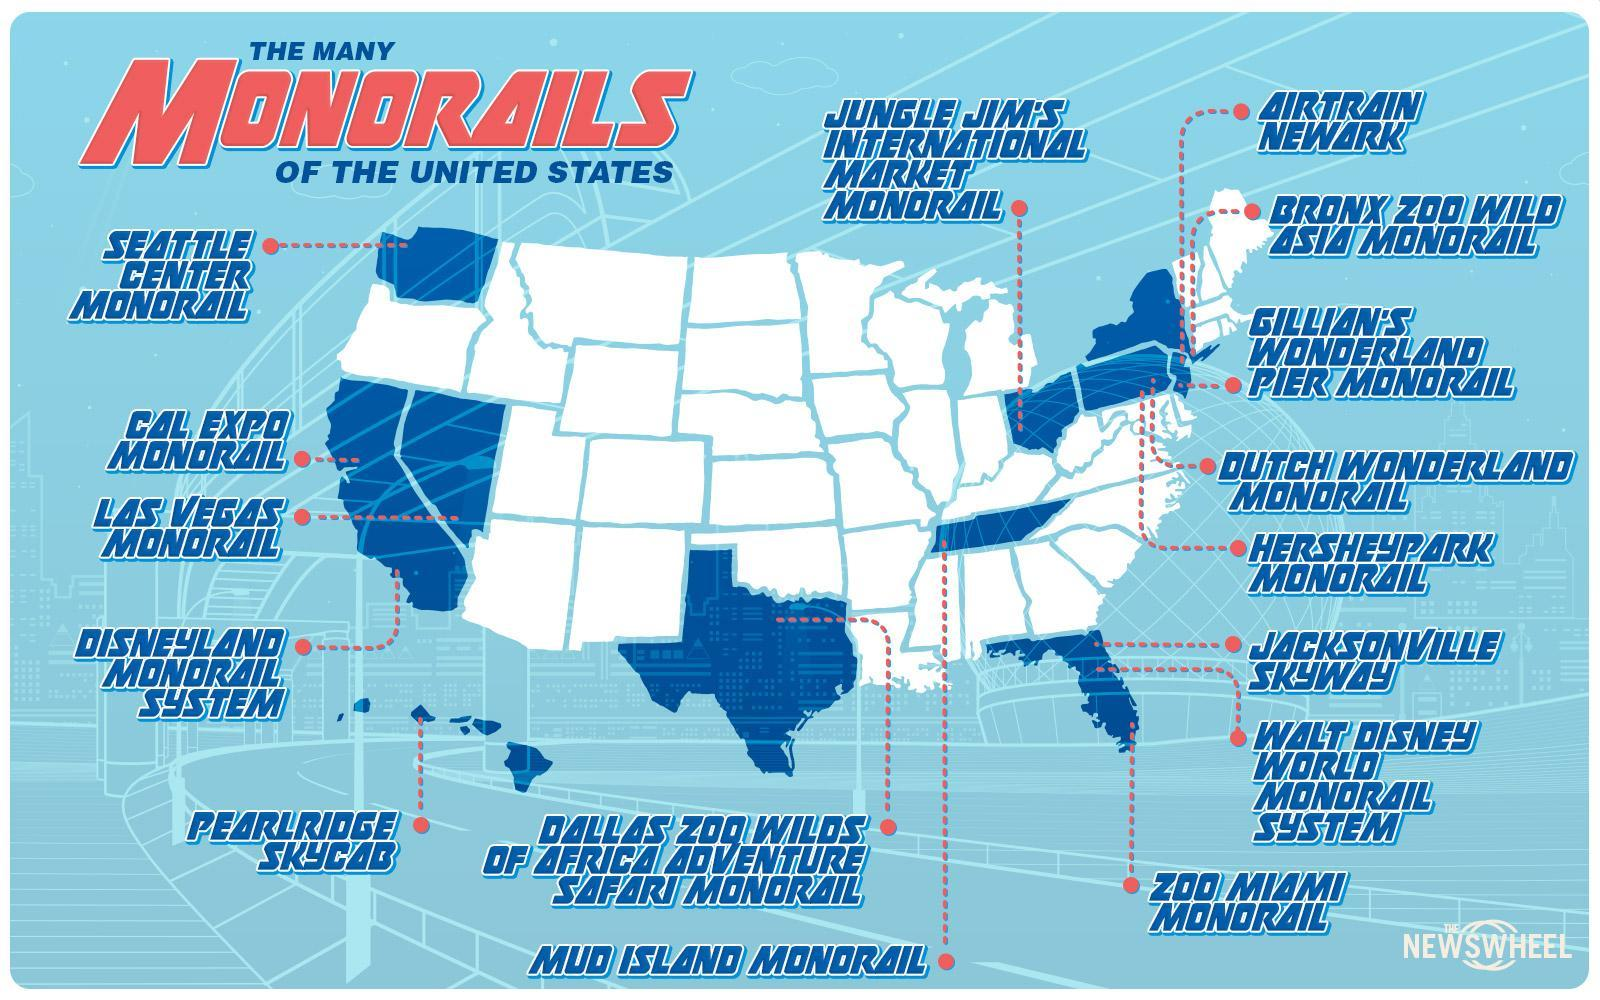How many Monorails are there in America?
Answer the question with a short phrase. 16 What is the name of the monorail situated in the extreme east of United States? Bronx Zoo Wild Asia Monorail What is the name of the monorail located in the islands of United States? Pearlridge Skycab Which is the monorail located towards the North west of United states? Seattle Center Monorail 